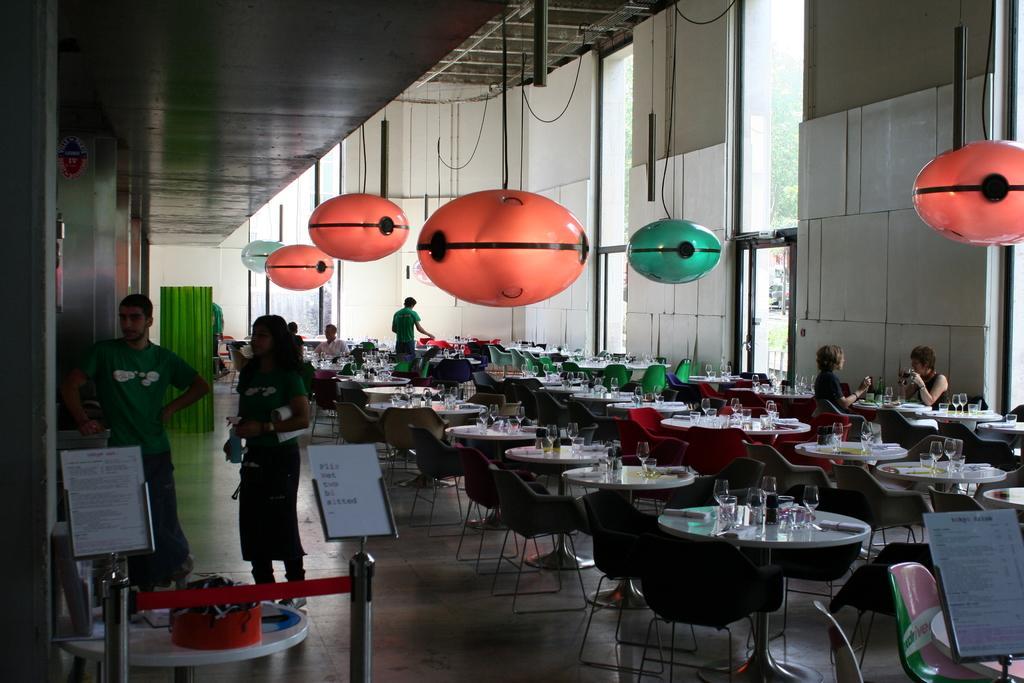How would you summarize this image in a sentence or two? This is the inside view of a restaurant where we can see so many tables and chairs. On the tables, we can see the glasses. On the left side of the image, we can see two people are standing. At the bottom of the image, we can see stands and papers. In the background, we can see wall and windows. Behind the windows, we can see trees. At the top of the image, we can see the roof. Orange and blue color objects are hang from the roof. 